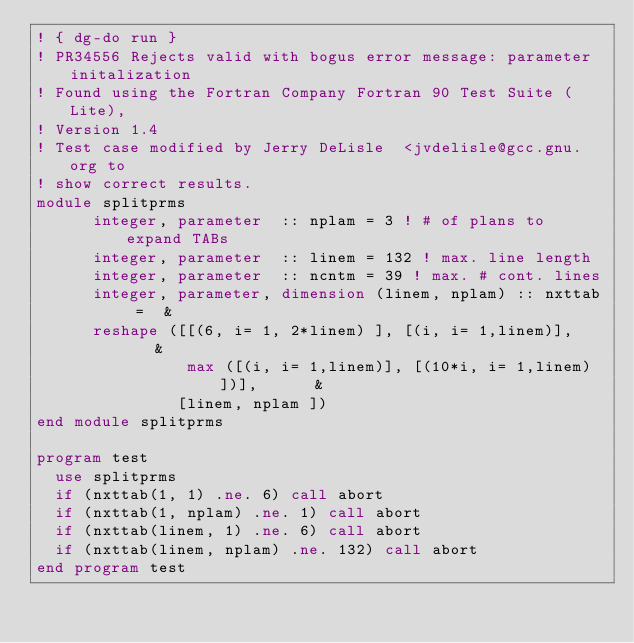<code> <loc_0><loc_0><loc_500><loc_500><_FORTRAN_>! { dg-do run }
! PR34556 Rejects valid with bogus error message: parameter initalization
! Found using the Fortran Company Fortran 90 Test Suite (Lite),
! Version 1.4
! Test case modified by Jerry DeLisle  <jvdelisle@gcc.gnu.org to
! show correct results.
module splitprms
      integer, parameter  :: nplam = 3 ! # of plans to expand TABs
      integer, parameter  :: linem = 132 ! max. line length
      integer, parameter  :: ncntm = 39 ! max. # cont. lines
      integer, parameter, dimension (linem, nplam) :: nxttab =  &
      reshape ([[(6, i= 1, 2*linem) ], [(i, i= 1,linem)],    &
                max ([(i, i= 1,linem)], [(10*i, i= 1,linem)])],      &
               [linem, nplam ])
end module splitprms

program test
  use splitprms
  if (nxttab(1, 1) .ne. 6) call abort
  if (nxttab(1, nplam) .ne. 1) call abort
  if (nxttab(linem, 1) .ne. 6) call abort
  if (nxttab(linem, nplam) .ne. 132) call abort
end program test
</code> 